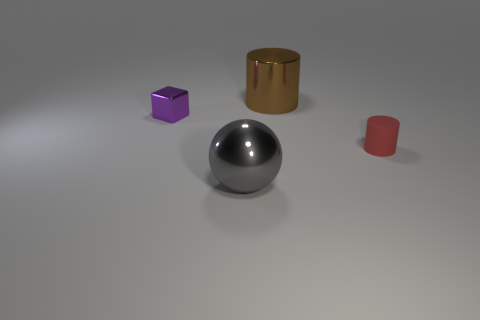Add 3 matte cylinders. How many objects exist? 7 Subtract all spheres. How many objects are left? 3 Subtract all gray metallic balls. Subtract all cylinders. How many objects are left? 1 Add 3 small things. How many small things are left? 5 Add 4 balls. How many balls exist? 5 Subtract 0 green cylinders. How many objects are left? 4 Subtract all gray blocks. Subtract all purple cylinders. How many blocks are left? 1 